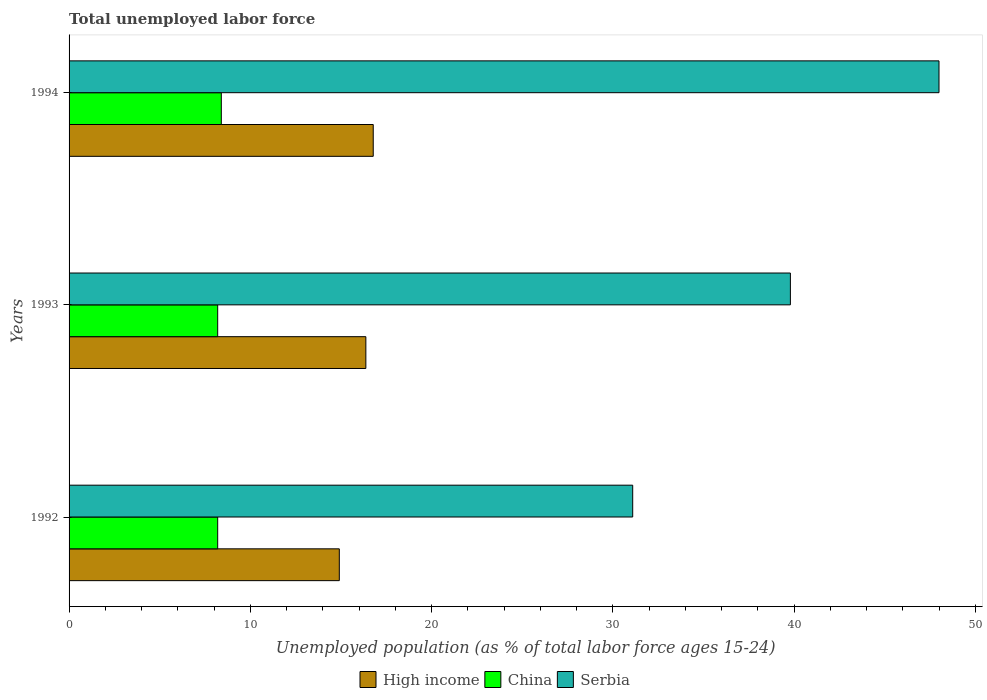How many different coloured bars are there?
Your answer should be compact. 3. Are the number of bars per tick equal to the number of legend labels?
Offer a very short reply. Yes. Are the number of bars on each tick of the Y-axis equal?
Your answer should be compact. Yes. How many bars are there on the 3rd tick from the bottom?
Offer a terse response. 3. What is the label of the 2nd group of bars from the top?
Keep it short and to the point. 1993. In how many cases, is the number of bars for a given year not equal to the number of legend labels?
Your response must be concise. 0. What is the percentage of unemployed population in in Serbia in 1992?
Provide a short and direct response. 31.1. Across all years, what is the maximum percentage of unemployed population in in Serbia?
Offer a very short reply. 48. Across all years, what is the minimum percentage of unemployed population in in China?
Provide a short and direct response. 8.2. What is the total percentage of unemployed population in in High income in the graph?
Your answer should be very brief. 48.07. What is the difference between the percentage of unemployed population in in High income in 1992 and that in 1994?
Your response must be concise. -1.87. What is the difference between the percentage of unemployed population in in High income in 1992 and the percentage of unemployed population in in China in 1994?
Provide a short and direct response. 6.51. What is the average percentage of unemployed population in in High income per year?
Your response must be concise. 16.02. In the year 1994, what is the difference between the percentage of unemployed population in in China and percentage of unemployed population in in High income?
Provide a short and direct response. -8.38. What is the ratio of the percentage of unemployed population in in Serbia in 1992 to that in 1994?
Give a very brief answer. 0.65. Is the percentage of unemployed population in in Serbia in 1992 less than that in 1994?
Your response must be concise. Yes. What is the difference between the highest and the second highest percentage of unemployed population in in High income?
Give a very brief answer. 0.41. What is the difference between the highest and the lowest percentage of unemployed population in in High income?
Offer a very short reply. 1.87. Is it the case that in every year, the sum of the percentage of unemployed population in in High income and percentage of unemployed population in in Serbia is greater than the percentage of unemployed population in in China?
Provide a short and direct response. Yes. How many bars are there?
Your response must be concise. 9. Are all the bars in the graph horizontal?
Ensure brevity in your answer.  Yes. What is the difference between two consecutive major ticks on the X-axis?
Give a very brief answer. 10. Are the values on the major ticks of X-axis written in scientific E-notation?
Your answer should be compact. No. Does the graph contain any zero values?
Give a very brief answer. No. Does the graph contain grids?
Provide a succinct answer. No. How many legend labels are there?
Offer a very short reply. 3. What is the title of the graph?
Keep it short and to the point. Total unemployed labor force. Does "Slovenia" appear as one of the legend labels in the graph?
Keep it short and to the point. No. What is the label or title of the X-axis?
Your response must be concise. Unemployed population (as % of total labor force ages 15-24). What is the label or title of the Y-axis?
Your response must be concise. Years. What is the Unemployed population (as % of total labor force ages 15-24) in High income in 1992?
Offer a terse response. 14.91. What is the Unemployed population (as % of total labor force ages 15-24) of China in 1992?
Make the answer very short. 8.2. What is the Unemployed population (as % of total labor force ages 15-24) of Serbia in 1992?
Give a very brief answer. 31.1. What is the Unemployed population (as % of total labor force ages 15-24) of High income in 1993?
Offer a terse response. 16.38. What is the Unemployed population (as % of total labor force ages 15-24) of China in 1993?
Offer a terse response. 8.2. What is the Unemployed population (as % of total labor force ages 15-24) of Serbia in 1993?
Offer a very short reply. 39.8. What is the Unemployed population (as % of total labor force ages 15-24) in High income in 1994?
Offer a very short reply. 16.78. What is the Unemployed population (as % of total labor force ages 15-24) of China in 1994?
Provide a short and direct response. 8.4. Across all years, what is the maximum Unemployed population (as % of total labor force ages 15-24) of High income?
Provide a short and direct response. 16.78. Across all years, what is the maximum Unemployed population (as % of total labor force ages 15-24) of China?
Your answer should be compact. 8.4. Across all years, what is the minimum Unemployed population (as % of total labor force ages 15-24) of High income?
Offer a very short reply. 14.91. Across all years, what is the minimum Unemployed population (as % of total labor force ages 15-24) in China?
Keep it short and to the point. 8.2. Across all years, what is the minimum Unemployed population (as % of total labor force ages 15-24) in Serbia?
Provide a succinct answer. 31.1. What is the total Unemployed population (as % of total labor force ages 15-24) in High income in the graph?
Ensure brevity in your answer.  48.07. What is the total Unemployed population (as % of total labor force ages 15-24) in China in the graph?
Give a very brief answer. 24.8. What is the total Unemployed population (as % of total labor force ages 15-24) in Serbia in the graph?
Your response must be concise. 118.9. What is the difference between the Unemployed population (as % of total labor force ages 15-24) of High income in 1992 and that in 1993?
Keep it short and to the point. -1.46. What is the difference between the Unemployed population (as % of total labor force ages 15-24) in China in 1992 and that in 1993?
Your response must be concise. 0. What is the difference between the Unemployed population (as % of total labor force ages 15-24) in High income in 1992 and that in 1994?
Your answer should be compact. -1.87. What is the difference between the Unemployed population (as % of total labor force ages 15-24) of China in 1992 and that in 1994?
Offer a terse response. -0.2. What is the difference between the Unemployed population (as % of total labor force ages 15-24) in Serbia in 1992 and that in 1994?
Provide a succinct answer. -16.9. What is the difference between the Unemployed population (as % of total labor force ages 15-24) in High income in 1993 and that in 1994?
Give a very brief answer. -0.41. What is the difference between the Unemployed population (as % of total labor force ages 15-24) of China in 1993 and that in 1994?
Your answer should be very brief. -0.2. What is the difference between the Unemployed population (as % of total labor force ages 15-24) of Serbia in 1993 and that in 1994?
Provide a short and direct response. -8.2. What is the difference between the Unemployed population (as % of total labor force ages 15-24) in High income in 1992 and the Unemployed population (as % of total labor force ages 15-24) in China in 1993?
Provide a succinct answer. 6.71. What is the difference between the Unemployed population (as % of total labor force ages 15-24) of High income in 1992 and the Unemployed population (as % of total labor force ages 15-24) of Serbia in 1993?
Make the answer very short. -24.89. What is the difference between the Unemployed population (as % of total labor force ages 15-24) of China in 1992 and the Unemployed population (as % of total labor force ages 15-24) of Serbia in 1993?
Your response must be concise. -31.6. What is the difference between the Unemployed population (as % of total labor force ages 15-24) of High income in 1992 and the Unemployed population (as % of total labor force ages 15-24) of China in 1994?
Ensure brevity in your answer.  6.51. What is the difference between the Unemployed population (as % of total labor force ages 15-24) in High income in 1992 and the Unemployed population (as % of total labor force ages 15-24) in Serbia in 1994?
Provide a short and direct response. -33.09. What is the difference between the Unemployed population (as % of total labor force ages 15-24) in China in 1992 and the Unemployed population (as % of total labor force ages 15-24) in Serbia in 1994?
Offer a terse response. -39.8. What is the difference between the Unemployed population (as % of total labor force ages 15-24) of High income in 1993 and the Unemployed population (as % of total labor force ages 15-24) of China in 1994?
Provide a short and direct response. 7.98. What is the difference between the Unemployed population (as % of total labor force ages 15-24) in High income in 1993 and the Unemployed population (as % of total labor force ages 15-24) in Serbia in 1994?
Ensure brevity in your answer.  -31.62. What is the difference between the Unemployed population (as % of total labor force ages 15-24) of China in 1993 and the Unemployed population (as % of total labor force ages 15-24) of Serbia in 1994?
Your answer should be very brief. -39.8. What is the average Unemployed population (as % of total labor force ages 15-24) in High income per year?
Make the answer very short. 16.02. What is the average Unemployed population (as % of total labor force ages 15-24) in China per year?
Give a very brief answer. 8.27. What is the average Unemployed population (as % of total labor force ages 15-24) of Serbia per year?
Offer a terse response. 39.63. In the year 1992, what is the difference between the Unemployed population (as % of total labor force ages 15-24) in High income and Unemployed population (as % of total labor force ages 15-24) in China?
Offer a very short reply. 6.71. In the year 1992, what is the difference between the Unemployed population (as % of total labor force ages 15-24) of High income and Unemployed population (as % of total labor force ages 15-24) of Serbia?
Provide a short and direct response. -16.19. In the year 1992, what is the difference between the Unemployed population (as % of total labor force ages 15-24) of China and Unemployed population (as % of total labor force ages 15-24) of Serbia?
Offer a terse response. -22.9. In the year 1993, what is the difference between the Unemployed population (as % of total labor force ages 15-24) of High income and Unemployed population (as % of total labor force ages 15-24) of China?
Your answer should be compact. 8.18. In the year 1993, what is the difference between the Unemployed population (as % of total labor force ages 15-24) in High income and Unemployed population (as % of total labor force ages 15-24) in Serbia?
Provide a succinct answer. -23.42. In the year 1993, what is the difference between the Unemployed population (as % of total labor force ages 15-24) of China and Unemployed population (as % of total labor force ages 15-24) of Serbia?
Your answer should be very brief. -31.6. In the year 1994, what is the difference between the Unemployed population (as % of total labor force ages 15-24) in High income and Unemployed population (as % of total labor force ages 15-24) in China?
Offer a very short reply. 8.38. In the year 1994, what is the difference between the Unemployed population (as % of total labor force ages 15-24) in High income and Unemployed population (as % of total labor force ages 15-24) in Serbia?
Offer a terse response. -31.22. In the year 1994, what is the difference between the Unemployed population (as % of total labor force ages 15-24) in China and Unemployed population (as % of total labor force ages 15-24) in Serbia?
Give a very brief answer. -39.6. What is the ratio of the Unemployed population (as % of total labor force ages 15-24) of High income in 1992 to that in 1993?
Your answer should be very brief. 0.91. What is the ratio of the Unemployed population (as % of total labor force ages 15-24) of China in 1992 to that in 1993?
Ensure brevity in your answer.  1. What is the ratio of the Unemployed population (as % of total labor force ages 15-24) of Serbia in 1992 to that in 1993?
Provide a succinct answer. 0.78. What is the ratio of the Unemployed population (as % of total labor force ages 15-24) in High income in 1992 to that in 1994?
Your answer should be compact. 0.89. What is the ratio of the Unemployed population (as % of total labor force ages 15-24) of China in 1992 to that in 1994?
Provide a short and direct response. 0.98. What is the ratio of the Unemployed population (as % of total labor force ages 15-24) in Serbia in 1992 to that in 1994?
Keep it short and to the point. 0.65. What is the ratio of the Unemployed population (as % of total labor force ages 15-24) in High income in 1993 to that in 1994?
Keep it short and to the point. 0.98. What is the ratio of the Unemployed population (as % of total labor force ages 15-24) of China in 1993 to that in 1994?
Ensure brevity in your answer.  0.98. What is the ratio of the Unemployed population (as % of total labor force ages 15-24) of Serbia in 1993 to that in 1994?
Your answer should be compact. 0.83. What is the difference between the highest and the second highest Unemployed population (as % of total labor force ages 15-24) of High income?
Keep it short and to the point. 0.41. What is the difference between the highest and the lowest Unemployed population (as % of total labor force ages 15-24) of High income?
Ensure brevity in your answer.  1.87. What is the difference between the highest and the lowest Unemployed population (as % of total labor force ages 15-24) of Serbia?
Make the answer very short. 16.9. 